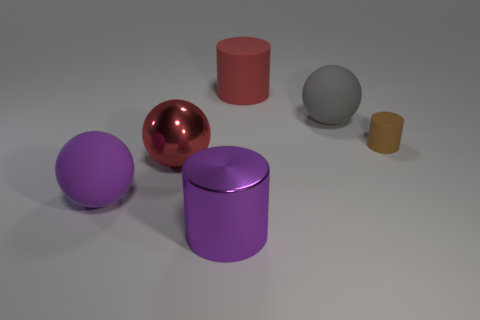The matte cylinder that is in front of the large cylinder behind the small thing is what color?
Your response must be concise. Brown. Do the purple rubber thing and the red metallic object have the same shape?
Offer a very short reply. Yes. What is the material of the big purple thing that is the same shape as the big gray rubber thing?
Offer a terse response. Rubber. Is there a matte thing that is on the right side of the big cylinder in front of the big shiny object left of the purple metallic cylinder?
Provide a succinct answer. Yes. There is a gray matte object; is it the same shape as the red object behind the tiny thing?
Give a very brief answer. No. Is there any other thing that is the same color as the small thing?
Your answer should be very brief. No. There is a big matte sphere in front of the tiny brown rubber cylinder; does it have the same color as the matte sphere that is right of the red ball?
Provide a short and direct response. No. Are any big gray matte balls visible?
Offer a terse response. Yes. Are there any big gray objects that have the same material as the purple ball?
Provide a short and direct response. Yes. The tiny rubber object has what color?
Your answer should be very brief. Brown. 